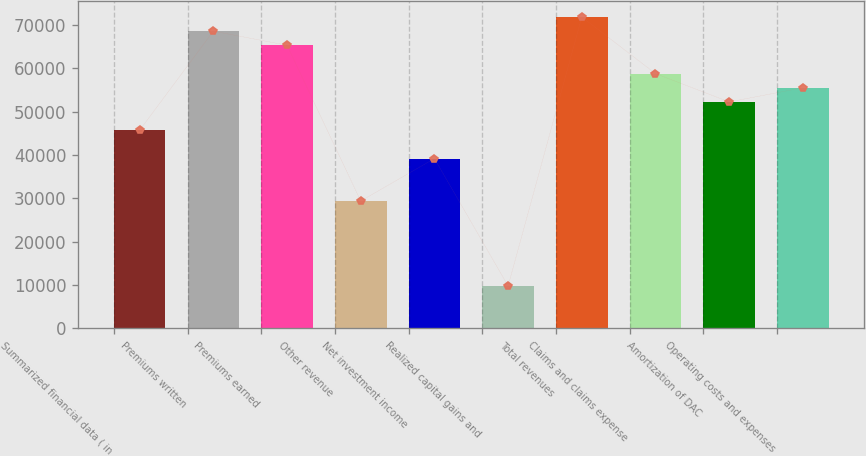Convert chart to OTSL. <chart><loc_0><loc_0><loc_500><loc_500><bar_chart><fcel>Summarized financial data ( in<fcel>Premiums written<fcel>Premiums earned<fcel>Other revenue<fcel>Net investment income<fcel>Realized capital gains and<fcel>Total revenues<fcel>Claims and claims expense<fcel>Amortization of DAC<fcel>Operating costs and expenses<nl><fcel>45726.8<fcel>68590.1<fcel>65323.9<fcel>29395.8<fcel>39194.4<fcel>9798.67<fcel>71856.3<fcel>58791.5<fcel>52259.1<fcel>55525.3<nl></chart> 